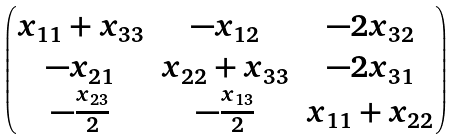Convert formula to latex. <formula><loc_0><loc_0><loc_500><loc_500>\begin{pmatrix} x _ { 1 1 } + x _ { 3 3 } & - x _ { 1 2 } & - 2 x _ { 3 2 } \\ - x _ { 2 1 } & x _ { 2 2 } + x _ { 3 3 } & - 2 x _ { 3 1 } \\ - \frac { x _ { 2 3 } } { 2 } & - \frac { x _ { 1 3 } } { 2 } & x _ { 1 1 } + x _ { 2 2 } \end{pmatrix}</formula> 